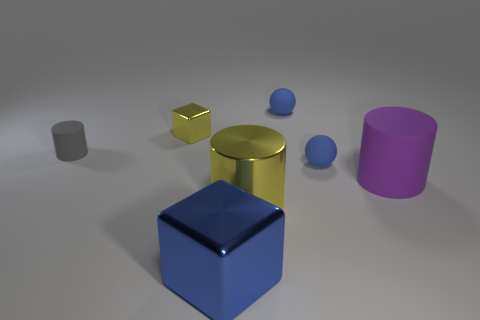How many blue spheres must be subtracted to get 1 blue spheres? 1 Add 1 green metal things. How many objects exist? 8 Subtract all cylinders. How many objects are left? 4 Add 5 large purple rubber things. How many large purple rubber things are left? 6 Add 2 tiny gray rubber cylinders. How many tiny gray rubber cylinders exist? 3 Subtract 0 brown blocks. How many objects are left? 7 Subtract all large green matte cylinders. Subtract all big purple objects. How many objects are left? 6 